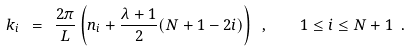Convert formula to latex. <formula><loc_0><loc_0><loc_500><loc_500>k _ { i } \ = \ \frac { 2 \pi } { L } \left ( n _ { i } + \frac { \lambda + 1 } { 2 } ( N + 1 - 2 i ) \right ) \ , \quad 1 \leq i \leq N + 1 \ .</formula> 